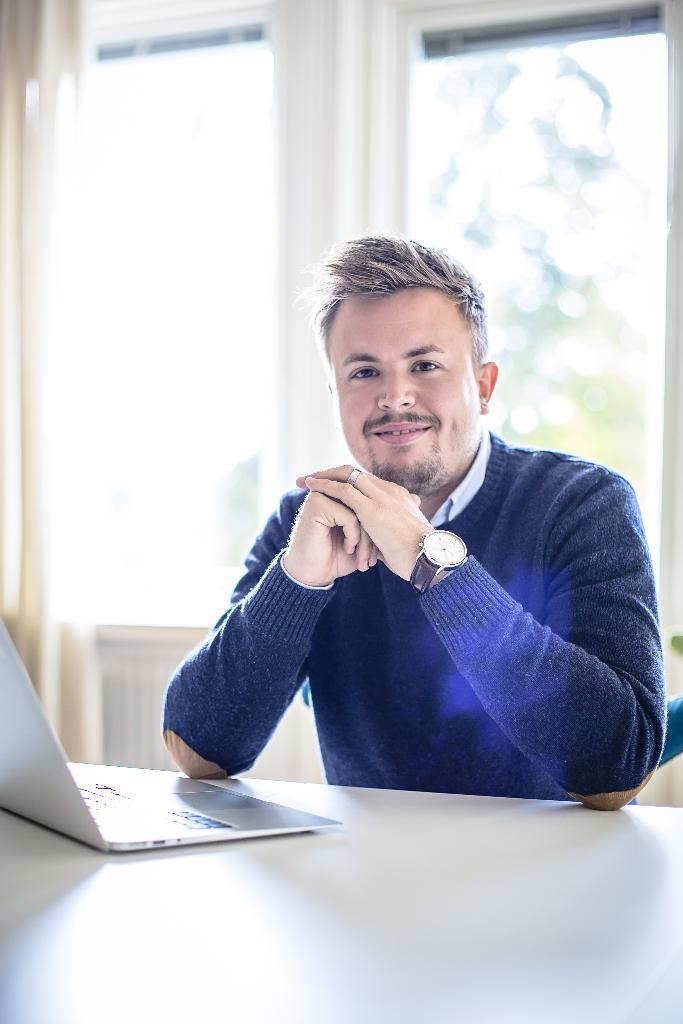Who is present in the image? There is a man in the image. What is the man doing in the image? The man is smiling in the image. What object can be seen on a table in the image? There is a laptop on a table in the image. What accessory is the man wearing in the image? The man is wearing a watch in the image. How many kittens are playing with the man's watch in the image? There are no kittens present in the image, and therefore no such activity can be observed. 